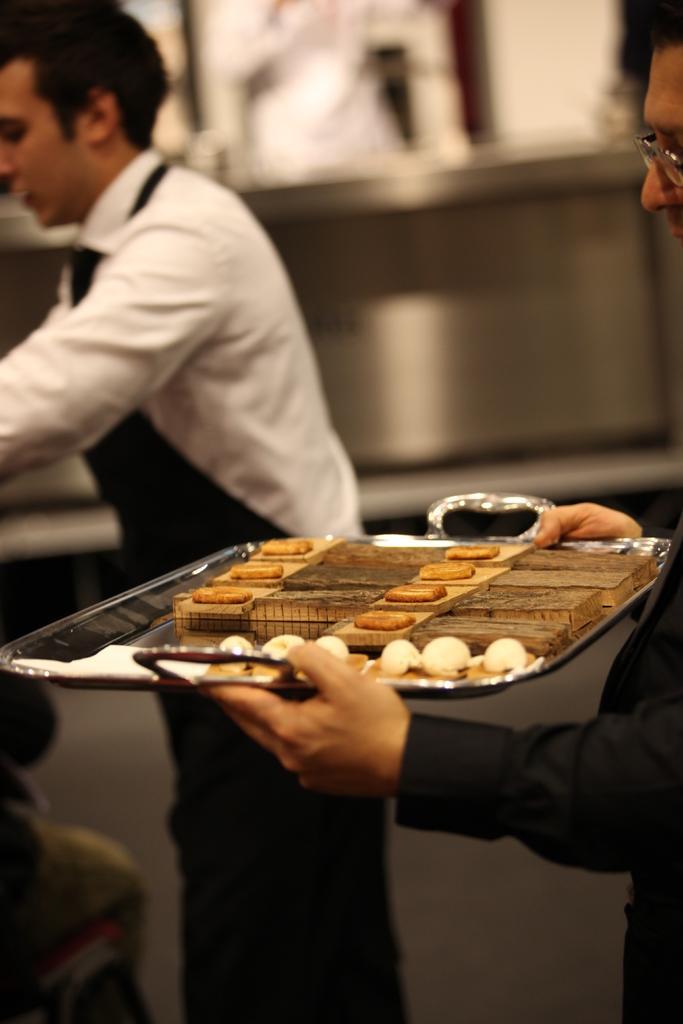Please provide a concise description of this image. In this image on the right side I can see a person holding a tray, on which I can see cookies, on the left I can see another person, background is blurry. 